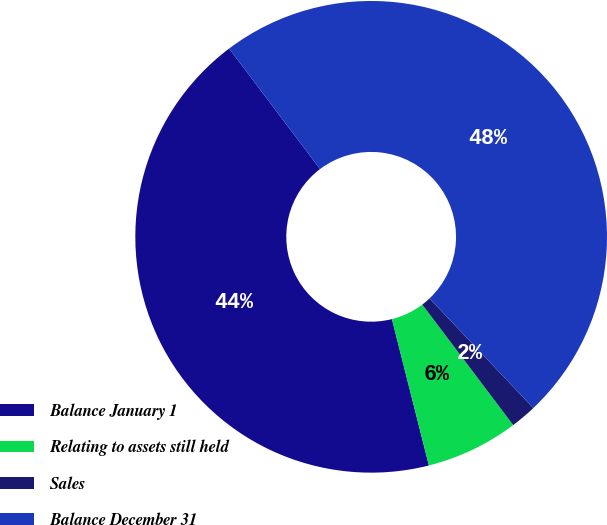Convert chart to OTSL. <chart><loc_0><loc_0><loc_500><loc_500><pie_chart><fcel>Balance January 1<fcel>Relating to assets still held<fcel>Sales<fcel>Balance December 31<nl><fcel>43.65%<fcel>6.35%<fcel>1.78%<fcel>48.22%<nl></chart> 